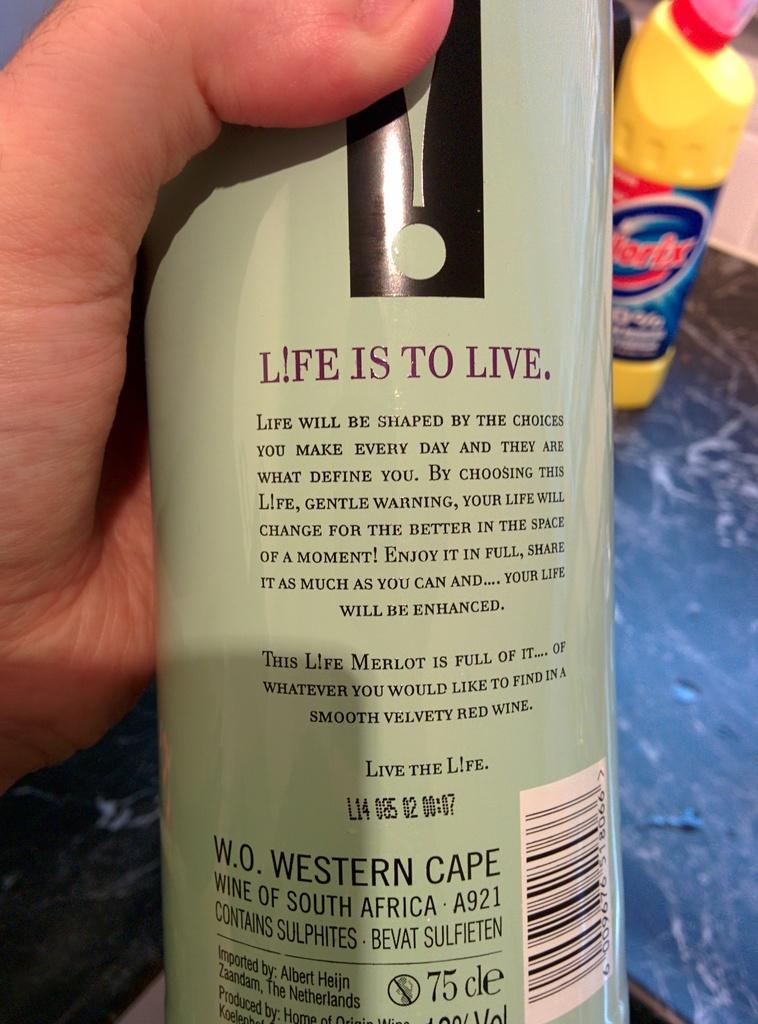Provide a one-sentence caption for the provided image. A bottle that claims Life is to live. 